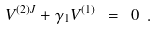Convert formula to latex. <formula><loc_0><loc_0><loc_500><loc_500>V ^ { ( 2 ) J } + \gamma _ { 1 } V ^ { ( 1 ) } \ = \ 0 \ .</formula> 